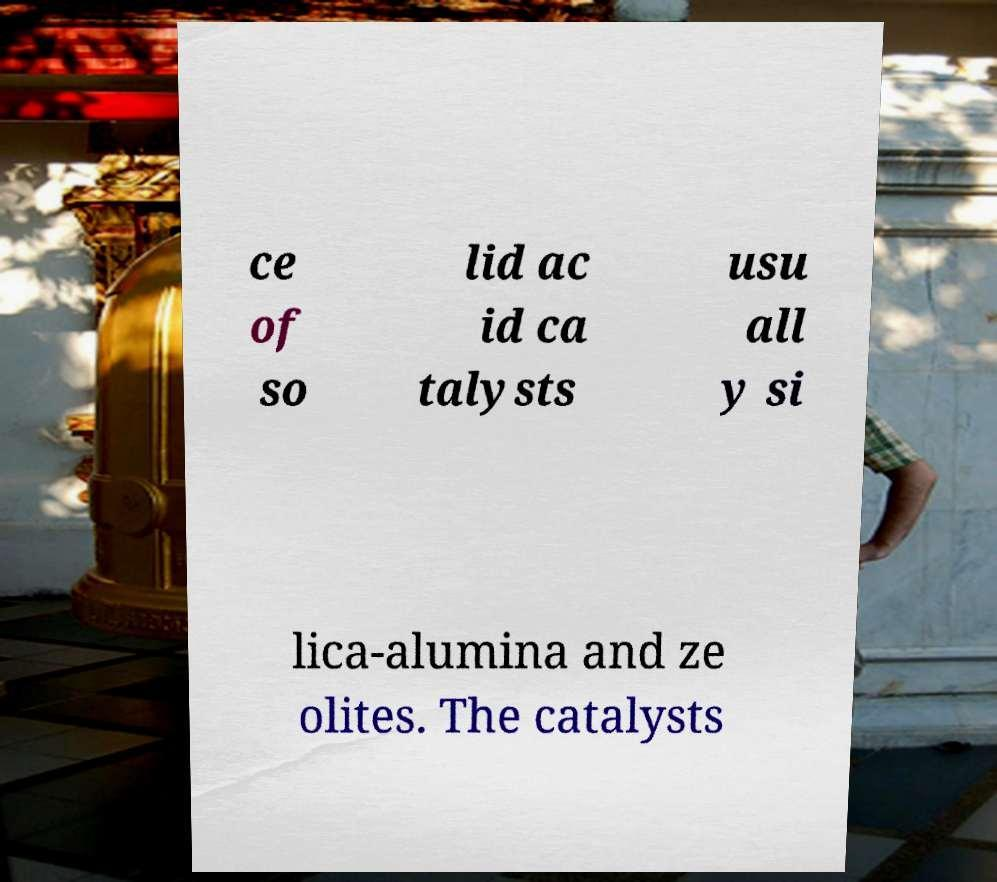I need the written content from this picture converted into text. Can you do that? ce of so lid ac id ca talysts usu all y si lica-alumina and ze olites. The catalysts 